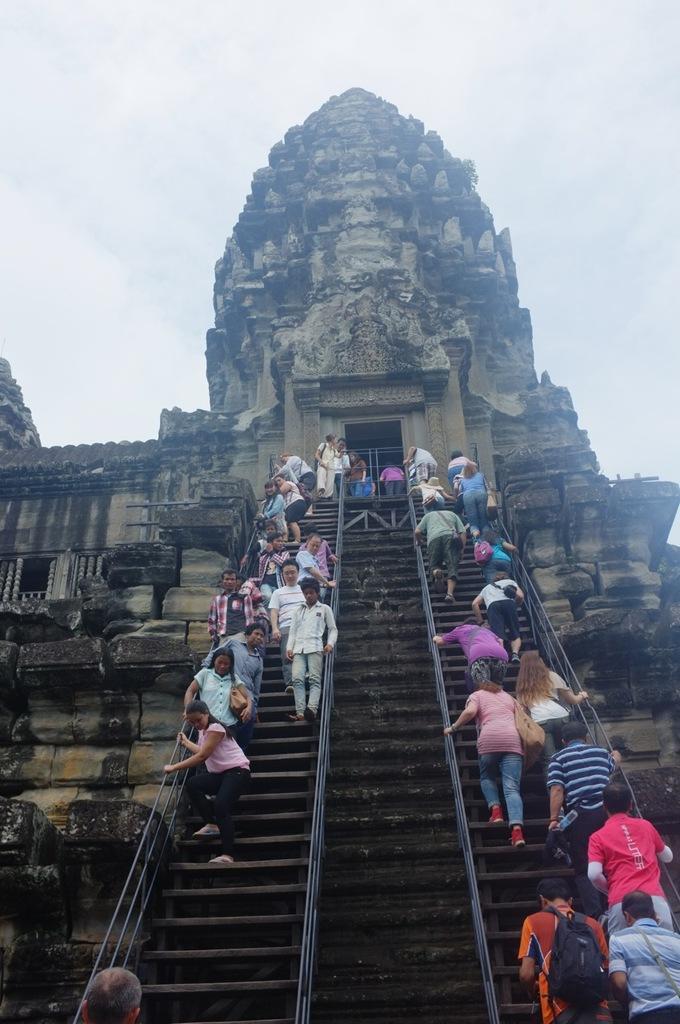Please provide a concise description of this image. In the image we can see there are people standing on the stairs and there is a building. There is a clear sky. 